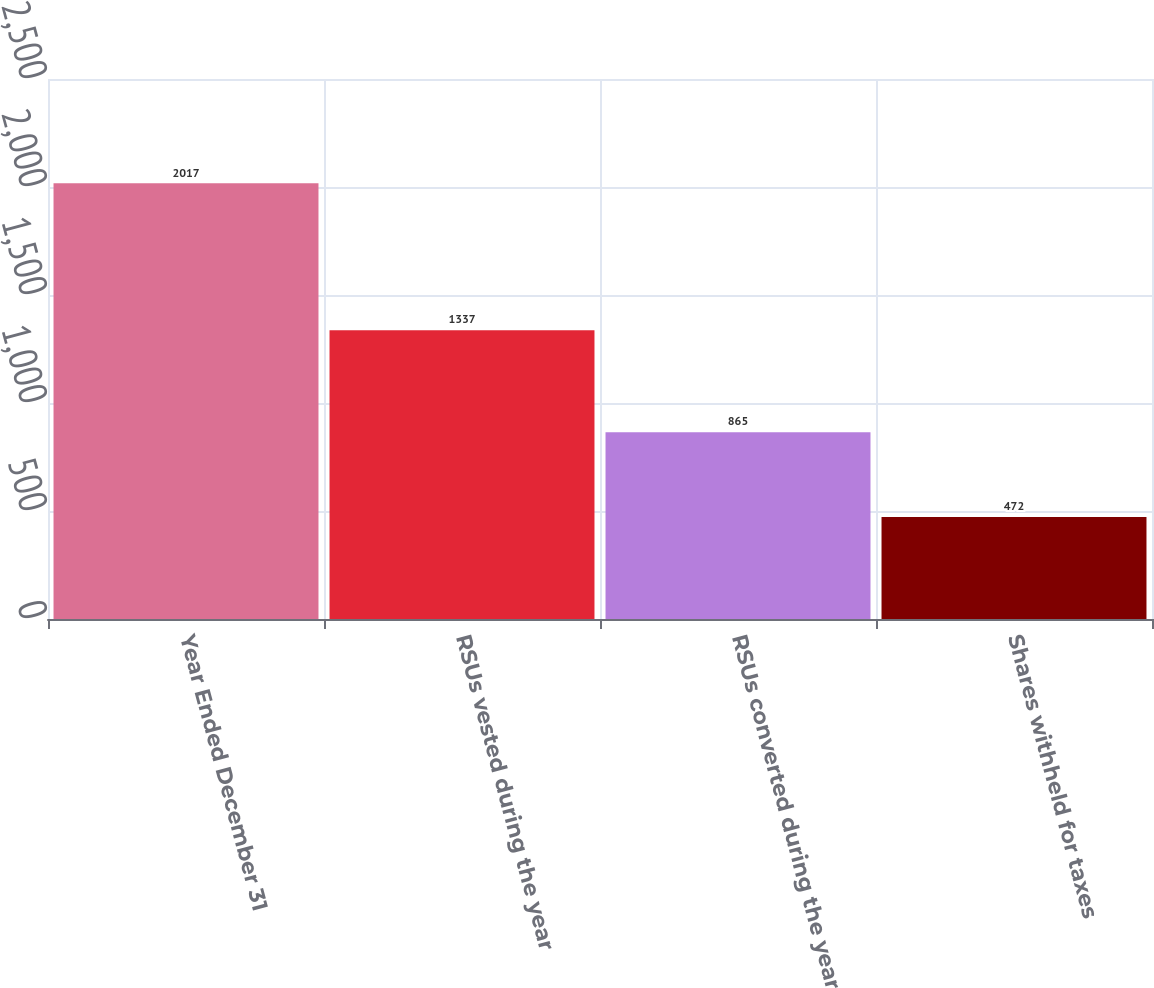<chart> <loc_0><loc_0><loc_500><loc_500><bar_chart><fcel>Year Ended December 31<fcel>RSUs vested during the year<fcel>RSUs converted during the year<fcel>Shares withheld for taxes<nl><fcel>2017<fcel>1337<fcel>865<fcel>472<nl></chart> 